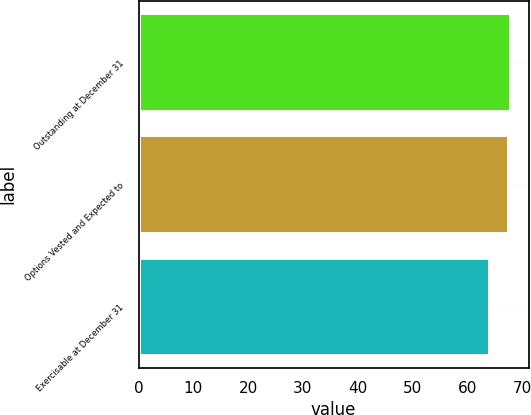Convert chart. <chart><loc_0><loc_0><loc_500><loc_500><bar_chart><fcel>Outstanding at December 31<fcel>Options Vested and Expected to<fcel>Exercisable at December 31<nl><fcel>67.81<fcel>67.46<fcel>64<nl></chart> 